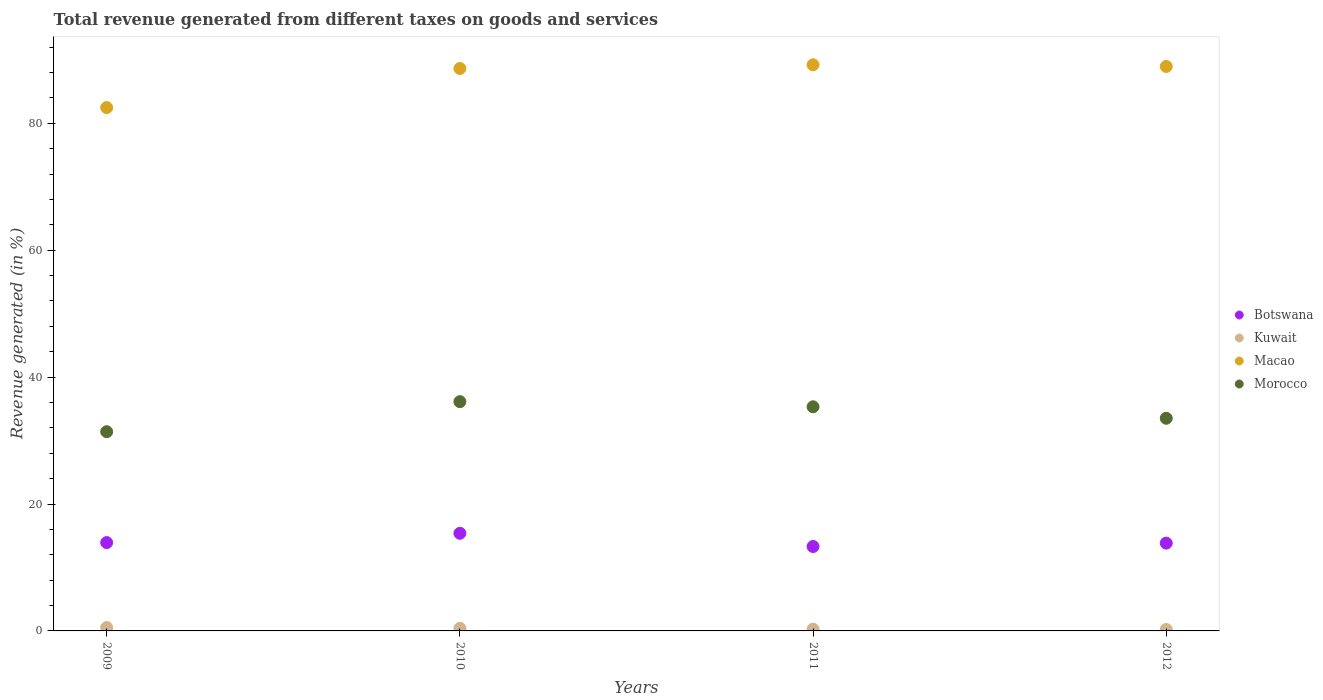Is the number of dotlines equal to the number of legend labels?
Your answer should be compact. Yes. What is the total revenue generated in Morocco in 2011?
Provide a short and direct response. 35.33. Across all years, what is the maximum total revenue generated in Botswana?
Give a very brief answer. 15.39. Across all years, what is the minimum total revenue generated in Macao?
Keep it short and to the point. 82.48. What is the total total revenue generated in Botswana in the graph?
Keep it short and to the point. 56.45. What is the difference between the total revenue generated in Morocco in 2009 and that in 2011?
Keep it short and to the point. -3.93. What is the difference between the total revenue generated in Macao in 2011 and the total revenue generated in Botswana in 2009?
Keep it short and to the point. 75.3. What is the average total revenue generated in Kuwait per year?
Keep it short and to the point. 0.37. In the year 2012, what is the difference between the total revenue generated in Botswana and total revenue generated in Morocco?
Provide a succinct answer. -19.68. What is the ratio of the total revenue generated in Botswana in 2009 to that in 2012?
Offer a terse response. 1.01. Is the difference between the total revenue generated in Botswana in 2009 and 2011 greater than the difference between the total revenue generated in Morocco in 2009 and 2011?
Ensure brevity in your answer.  Yes. What is the difference between the highest and the second highest total revenue generated in Botswana?
Your answer should be very brief. 1.46. What is the difference between the highest and the lowest total revenue generated in Macao?
Make the answer very short. 6.74. Is it the case that in every year, the sum of the total revenue generated in Macao and total revenue generated in Morocco  is greater than the sum of total revenue generated in Botswana and total revenue generated in Kuwait?
Offer a terse response. Yes. Is the total revenue generated in Morocco strictly greater than the total revenue generated in Kuwait over the years?
Offer a terse response. Yes. How many dotlines are there?
Offer a terse response. 4. How many years are there in the graph?
Give a very brief answer. 4. Are the values on the major ticks of Y-axis written in scientific E-notation?
Your response must be concise. No. Does the graph contain any zero values?
Provide a short and direct response. No. Where does the legend appear in the graph?
Your answer should be very brief. Center right. How many legend labels are there?
Your answer should be very brief. 4. What is the title of the graph?
Your answer should be compact. Total revenue generated from different taxes on goods and services. What is the label or title of the X-axis?
Keep it short and to the point. Years. What is the label or title of the Y-axis?
Keep it short and to the point. Revenue generated (in %). What is the Revenue generated (in %) of Botswana in 2009?
Your answer should be very brief. 13.92. What is the Revenue generated (in %) in Kuwait in 2009?
Your answer should be very brief. 0.54. What is the Revenue generated (in %) of Macao in 2009?
Ensure brevity in your answer.  82.48. What is the Revenue generated (in %) of Morocco in 2009?
Keep it short and to the point. 31.4. What is the Revenue generated (in %) in Botswana in 2010?
Provide a succinct answer. 15.39. What is the Revenue generated (in %) of Kuwait in 2010?
Your answer should be compact. 0.41. What is the Revenue generated (in %) in Macao in 2010?
Offer a very short reply. 88.65. What is the Revenue generated (in %) in Morocco in 2010?
Make the answer very short. 36.13. What is the Revenue generated (in %) in Botswana in 2011?
Offer a very short reply. 13.31. What is the Revenue generated (in %) of Kuwait in 2011?
Offer a very short reply. 0.29. What is the Revenue generated (in %) of Macao in 2011?
Your answer should be very brief. 89.22. What is the Revenue generated (in %) in Morocco in 2011?
Your response must be concise. 35.33. What is the Revenue generated (in %) of Botswana in 2012?
Offer a terse response. 13.84. What is the Revenue generated (in %) in Kuwait in 2012?
Give a very brief answer. 0.23. What is the Revenue generated (in %) in Macao in 2012?
Keep it short and to the point. 88.96. What is the Revenue generated (in %) of Morocco in 2012?
Your answer should be very brief. 33.52. Across all years, what is the maximum Revenue generated (in %) of Botswana?
Your answer should be compact. 15.39. Across all years, what is the maximum Revenue generated (in %) in Kuwait?
Give a very brief answer. 0.54. Across all years, what is the maximum Revenue generated (in %) of Macao?
Keep it short and to the point. 89.22. Across all years, what is the maximum Revenue generated (in %) in Morocco?
Provide a succinct answer. 36.13. Across all years, what is the minimum Revenue generated (in %) in Botswana?
Give a very brief answer. 13.31. Across all years, what is the minimum Revenue generated (in %) in Kuwait?
Offer a very short reply. 0.23. Across all years, what is the minimum Revenue generated (in %) in Macao?
Provide a short and direct response. 82.48. Across all years, what is the minimum Revenue generated (in %) of Morocco?
Your response must be concise. 31.4. What is the total Revenue generated (in %) in Botswana in the graph?
Your answer should be very brief. 56.45. What is the total Revenue generated (in %) in Kuwait in the graph?
Your response must be concise. 1.47. What is the total Revenue generated (in %) in Macao in the graph?
Provide a short and direct response. 349.31. What is the total Revenue generated (in %) of Morocco in the graph?
Offer a very short reply. 136.37. What is the difference between the Revenue generated (in %) in Botswana in 2009 and that in 2010?
Offer a terse response. -1.46. What is the difference between the Revenue generated (in %) of Kuwait in 2009 and that in 2010?
Offer a terse response. 0.12. What is the difference between the Revenue generated (in %) in Macao in 2009 and that in 2010?
Your response must be concise. -6.16. What is the difference between the Revenue generated (in %) of Morocco in 2009 and that in 2010?
Give a very brief answer. -4.73. What is the difference between the Revenue generated (in %) in Botswana in 2009 and that in 2011?
Offer a very short reply. 0.62. What is the difference between the Revenue generated (in %) of Kuwait in 2009 and that in 2011?
Your answer should be very brief. 0.25. What is the difference between the Revenue generated (in %) of Macao in 2009 and that in 2011?
Ensure brevity in your answer.  -6.74. What is the difference between the Revenue generated (in %) in Morocco in 2009 and that in 2011?
Provide a short and direct response. -3.93. What is the difference between the Revenue generated (in %) of Botswana in 2009 and that in 2012?
Offer a terse response. 0.09. What is the difference between the Revenue generated (in %) of Kuwait in 2009 and that in 2012?
Offer a very short reply. 0.3. What is the difference between the Revenue generated (in %) in Macao in 2009 and that in 2012?
Your answer should be very brief. -6.48. What is the difference between the Revenue generated (in %) of Morocco in 2009 and that in 2012?
Ensure brevity in your answer.  -2.12. What is the difference between the Revenue generated (in %) of Botswana in 2010 and that in 2011?
Offer a very short reply. 2.08. What is the difference between the Revenue generated (in %) of Kuwait in 2010 and that in 2011?
Give a very brief answer. 0.13. What is the difference between the Revenue generated (in %) in Macao in 2010 and that in 2011?
Your answer should be very brief. -0.58. What is the difference between the Revenue generated (in %) in Morocco in 2010 and that in 2011?
Provide a succinct answer. 0.81. What is the difference between the Revenue generated (in %) of Botswana in 2010 and that in 2012?
Your answer should be compact. 1.55. What is the difference between the Revenue generated (in %) of Kuwait in 2010 and that in 2012?
Provide a succinct answer. 0.18. What is the difference between the Revenue generated (in %) in Macao in 2010 and that in 2012?
Provide a succinct answer. -0.32. What is the difference between the Revenue generated (in %) in Morocco in 2010 and that in 2012?
Give a very brief answer. 2.62. What is the difference between the Revenue generated (in %) in Botswana in 2011 and that in 2012?
Provide a succinct answer. -0.53. What is the difference between the Revenue generated (in %) in Kuwait in 2011 and that in 2012?
Keep it short and to the point. 0.05. What is the difference between the Revenue generated (in %) of Macao in 2011 and that in 2012?
Offer a very short reply. 0.26. What is the difference between the Revenue generated (in %) of Morocco in 2011 and that in 2012?
Make the answer very short. 1.81. What is the difference between the Revenue generated (in %) of Botswana in 2009 and the Revenue generated (in %) of Kuwait in 2010?
Offer a terse response. 13.51. What is the difference between the Revenue generated (in %) of Botswana in 2009 and the Revenue generated (in %) of Macao in 2010?
Provide a succinct answer. -74.72. What is the difference between the Revenue generated (in %) in Botswana in 2009 and the Revenue generated (in %) in Morocco in 2010?
Offer a terse response. -22.21. What is the difference between the Revenue generated (in %) of Kuwait in 2009 and the Revenue generated (in %) of Macao in 2010?
Keep it short and to the point. -88.11. What is the difference between the Revenue generated (in %) of Kuwait in 2009 and the Revenue generated (in %) of Morocco in 2010?
Provide a short and direct response. -35.6. What is the difference between the Revenue generated (in %) in Macao in 2009 and the Revenue generated (in %) in Morocco in 2010?
Provide a succinct answer. 46.35. What is the difference between the Revenue generated (in %) in Botswana in 2009 and the Revenue generated (in %) in Kuwait in 2011?
Keep it short and to the point. 13.64. What is the difference between the Revenue generated (in %) in Botswana in 2009 and the Revenue generated (in %) in Macao in 2011?
Your response must be concise. -75.3. What is the difference between the Revenue generated (in %) of Botswana in 2009 and the Revenue generated (in %) of Morocco in 2011?
Provide a succinct answer. -21.4. What is the difference between the Revenue generated (in %) of Kuwait in 2009 and the Revenue generated (in %) of Macao in 2011?
Ensure brevity in your answer.  -88.69. What is the difference between the Revenue generated (in %) in Kuwait in 2009 and the Revenue generated (in %) in Morocco in 2011?
Ensure brevity in your answer.  -34.79. What is the difference between the Revenue generated (in %) of Macao in 2009 and the Revenue generated (in %) of Morocco in 2011?
Offer a very short reply. 47.16. What is the difference between the Revenue generated (in %) of Botswana in 2009 and the Revenue generated (in %) of Kuwait in 2012?
Make the answer very short. 13.69. What is the difference between the Revenue generated (in %) of Botswana in 2009 and the Revenue generated (in %) of Macao in 2012?
Offer a terse response. -75.04. What is the difference between the Revenue generated (in %) of Botswana in 2009 and the Revenue generated (in %) of Morocco in 2012?
Offer a very short reply. -19.59. What is the difference between the Revenue generated (in %) in Kuwait in 2009 and the Revenue generated (in %) in Macao in 2012?
Give a very brief answer. -88.42. What is the difference between the Revenue generated (in %) of Kuwait in 2009 and the Revenue generated (in %) of Morocco in 2012?
Ensure brevity in your answer.  -32.98. What is the difference between the Revenue generated (in %) of Macao in 2009 and the Revenue generated (in %) of Morocco in 2012?
Give a very brief answer. 48.97. What is the difference between the Revenue generated (in %) of Botswana in 2010 and the Revenue generated (in %) of Kuwait in 2011?
Your answer should be very brief. 15.1. What is the difference between the Revenue generated (in %) in Botswana in 2010 and the Revenue generated (in %) in Macao in 2011?
Give a very brief answer. -73.84. What is the difference between the Revenue generated (in %) in Botswana in 2010 and the Revenue generated (in %) in Morocco in 2011?
Give a very brief answer. -19.94. What is the difference between the Revenue generated (in %) in Kuwait in 2010 and the Revenue generated (in %) in Macao in 2011?
Ensure brevity in your answer.  -88.81. What is the difference between the Revenue generated (in %) of Kuwait in 2010 and the Revenue generated (in %) of Morocco in 2011?
Offer a terse response. -34.91. What is the difference between the Revenue generated (in %) in Macao in 2010 and the Revenue generated (in %) in Morocco in 2011?
Offer a very short reply. 53.32. What is the difference between the Revenue generated (in %) in Botswana in 2010 and the Revenue generated (in %) in Kuwait in 2012?
Provide a succinct answer. 15.15. What is the difference between the Revenue generated (in %) in Botswana in 2010 and the Revenue generated (in %) in Macao in 2012?
Ensure brevity in your answer.  -73.57. What is the difference between the Revenue generated (in %) in Botswana in 2010 and the Revenue generated (in %) in Morocco in 2012?
Ensure brevity in your answer.  -18.13. What is the difference between the Revenue generated (in %) in Kuwait in 2010 and the Revenue generated (in %) in Macao in 2012?
Provide a short and direct response. -88.55. What is the difference between the Revenue generated (in %) of Kuwait in 2010 and the Revenue generated (in %) of Morocco in 2012?
Ensure brevity in your answer.  -33.1. What is the difference between the Revenue generated (in %) of Macao in 2010 and the Revenue generated (in %) of Morocco in 2012?
Offer a very short reply. 55.13. What is the difference between the Revenue generated (in %) of Botswana in 2011 and the Revenue generated (in %) of Kuwait in 2012?
Your response must be concise. 13.07. What is the difference between the Revenue generated (in %) of Botswana in 2011 and the Revenue generated (in %) of Macao in 2012?
Make the answer very short. -75.65. What is the difference between the Revenue generated (in %) of Botswana in 2011 and the Revenue generated (in %) of Morocco in 2012?
Make the answer very short. -20.21. What is the difference between the Revenue generated (in %) of Kuwait in 2011 and the Revenue generated (in %) of Macao in 2012?
Keep it short and to the point. -88.67. What is the difference between the Revenue generated (in %) in Kuwait in 2011 and the Revenue generated (in %) in Morocco in 2012?
Your response must be concise. -33.23. What is the difference between the Revenue generated (in %) in Macao in 2011 and the Revenue generated (in %) in Morocco in 2012?
Ensure brevity in your answer.  55.71. What is the average Revenue generated (in %) of Botswana per year?
Give a very brief answer. 14.11. What is the average Revenue generated (in %) in Kuwait per year?
Your answer should be compact. 0.37. What is the average Revenue generated (in %) in Macao per year?
Make the answer very short. 87.33. What is the average Revenue generated (in %) of Morocco per year?
Keep it short and to the point. 34.09. In the year 2009, what is the difference between the Revenue generated (in %) of Botswana and Revenue generated (in %) of Kuwait?
Your response must be concise. 13.39. In the year 2009, what is the difference between the Revenue generated (in %) in Botswana and Revenue generated (in %) in Macao?
Your answer should be compact. -68.56. In the year 2009, what is the difference between the Revenue generated (in %) of Botswana and Revenue generated (in %) of Morocco?
Ensure brevity in your answer.  -17.48. In the year 2009, what is the difference between the Revenue generated (in %) in Kuwait and Revenue generated (in %) in Macao?
Make the answer very short. -81.95. In the year 2009, what is the difference between the Revenue generated (in %) of Kuwait and Revenue generated (in %) of Morocco?
Provide a short and direct response. -30.86. In the year 2009, what is the difference between the Revenue generated (in %) of Macao and Revenue generated (in %) of Morocco?
Provide a short and direct response. 51.08. In the year 2010, what is the difference between the Revenue generated (in %) in Botswana and Revenue generated (in %) in Kuwait?
Provide a succinct answer. 14.97. In the year 2010, what is the difference between the Revenue generated (in %) in Botswana and Revenue generated (in %) in Macao?
Provide a succinct answer. -73.26. In the year 2010, what is the difference between the Revenue generated (in %) of Botswana and Revenue generated (in %) of Morocco?
Offer a terse response. -20.75. In the year 2010, what is the difference between the Revenue generated (in %) in Kuwait and Revenue generated (in %) in Macao?
Ensure brevity in your answer.  -88.23. In the year 2010, what is the difference between the Revenue generated (in %) in Kuwait and Revenue generated (in %) in Morocco?
Provide a short and direct response. -35.72. In the year 2010, what is the difference between the Revenue generated (in %) in Macao and Revenue generated (in %) in Morocco?
Your response must be concise. 52.51. In the year 2011, what is the difference between the Revenue generated (in %) of Botswana and Revenue generated (in %) of Kuwait?
Provide a short and direct response. 13.02. In the year 2011, what is the difference between the Revenue generated (in %) of Botswana and Revenue generated (in %) of Macao?
Give a very brief answer. -75.92. In the year 2011, what is the difference between the Revenue generated (in %) of Botswana and Revenue generated (in %) of Morocco?
Make the answer very short. -22.02. In the year 2011, what is the difference between the Revenue generated (in %) of Kuwait and Revenue generated (in %) of Macao?
Your answer should be compact. -88.94. In the year 2011, what is the difference between the Revenue generated (in %) in Kuwait and Revenue generated (in %) in Morocco?
Your answer should be very brief. -35.04. In the year 2011, what is the difference between the Revenue generated (in %) in Macao and Revenue generated (in %) in Morocco?
Offer a very short reply. 53.9. In the year 2012, what is the difference between the Revenue generated (in %) in Botswana and Revenue generated (in %) in Kuwait?
Offer a terse response. 13.6. In the year 2012, what is the difference between the Revenue generated (in %) of Botswana and Revenue generated (in %) of Macao?
Your answer should be compact. -75.12. In the year 2012, what is the difference between the Revenue generated (in %) in Botswana and Revenue generated (in %) in Morocco?
Offer a terse response. -19.68. In the year 2012, what is the difference between the Revenue generated (in %) in Kuwait and Revenue generated (in %) in Macao?
Keep it short and to the point. -88.73. In the year 2012, what is the difference between the Revenue generated (in %) in Kuwait and Revenue generated (in %) in Morocco?
Offer a terse response. -33.28. In the year 2012, what is the difference between the Revenue generated (in %) in Macao and Revenue generated (in %) in Morocco?
Give a very brief answer. 55.45. What is the ratio of the Revenue generated (in %) of Botswana in 2009 to that in 2010?
Offer a very short reply. 0.9. What is the ratio of the Revenue generated (in %) of Kuwait in 2009 to that in 2010?
Offer a very short reply. 1.3. What is the ratio of the Revenue generated (in %) of Macao in 2009 to that in 2010?
Make the answer very short. 0.93. What is the ratio of the Revenue generated (in %) in Morocco in 2009 to that in 2010?
Offer a very short reply. 0.87. What is the ratio of the Revenue generated (in %) in Botswana in 2009 to that in 2011?
Provide a succinct answer. 1.05. What is the ratio of the Revenue generated (in %) of Kuwait in 2009 to that in 2011?
Offer a terse response. 1.87. What is the ratio of the Revenue generated (in %) of Macao in 2009 to that in 2011?
Give a very brief answer. 0.92. What is the ratio of the Revenue generated (in %) of Morocco in 2009 to that in 2011?
Make the answer very short. 0.89. What is the ratio of the Revenue generated (in %) of Kuwait in 2009 to that in 2012?
Your response must be concise. 2.3. What is the ratio of the Revenue generated (in %) in Macao in 2009 to that in 2012?
Make the answer very short. 0.93. What is the ratio of the Revenue generated (in %) in Morocco in 2009 to that in 2012?
Ensure brevity in your answer.  0.94. What is the ratio of the Revenue generated (in %) of Botswana in 2010 to that in 2011?
Make the answer very short. 1.16. What is the ratio of the Revenue generated (in %) in Kuwait in 2010 to that in 2011?
Ensure brevity in your answer.  1.44. What is the ratio of the Revenue generated (in %) in Macao in 2010 to that in 2011?
Your answer should be compact. 0.99. What is the ratio of the Revenue generated (in %) of Morocco in 2010 to that in 2011?
Ensure brevity in your answer.  1.02. What is the ratio of the Revenue generated (in %) of Botswana in 2010 to that in 2012?
Offer a terse response. 1.11. What is the ratio of the Revenue generated (in %) of Kuwait in 2010 to that in 2012?
Ensure brevity in your answer.  1.77. What is the ratio of the Revenue generated (in %) of Morocco in 2010 to that in 2012?
Provide a short and direct response. 1.08. What is the ratio of the Revenue generated (in %) in Botswana in 2011 to that in 2012?
Make the answer very short. 0.96. What is the ratio of the Revenue generated (in %) of Kuwait in 2011 to that in 2012?
Your answer should be compact. 1.23. What is the ratio of the Revenue generated (in %) of Macao in 2011 to that in 2012?
Give a very brief answer. 1. What is the ratio of the Revenue generated (in %) in Morocco in 2011 to that in 2012?
Your response must be concise. 1.05. What is the difference between the highest and the second highest Revenue generated (in %) in Botswana?
Offer a very short reply. 1.46. What is the difference between the highest and the second highest Revenue generated (in %) of Kuwait?
Provide a succinct answer. 0.12. What is the difference between the highest and the second highest Revenue generated (in %) of Macao?
Provide a succinct answer. 0.26. What is the difference between the highest and the second highest Revenue generated (in %) in Morocco?
Keep it short and to the point. 0.81. What is the difference between the highest and the lowest Revenue generated (in %) of Botswana?
Keep it short and to the point. 2.08. What is the difference between the highest and the lowest Revenue generated (in %) in Kuwait?
Offer a very short reply. 0.3. What is the difference between the highest and the lowest Revenue generated (in %) of Macao?
Give a very brief answer. 6.74. What is the difference between the highest and the lowest Revenue generated (in %) of Morocco?
Your answer should be very brief. 4.73. 